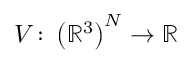Convert formula to latex. <formula><loc_0><loc_0><loc_500><loc_500>V \colon \left ( \mathbb { R } ^ { 3 } \right ) ^ { N } \rightarrow \mathbb { R }</formula> 